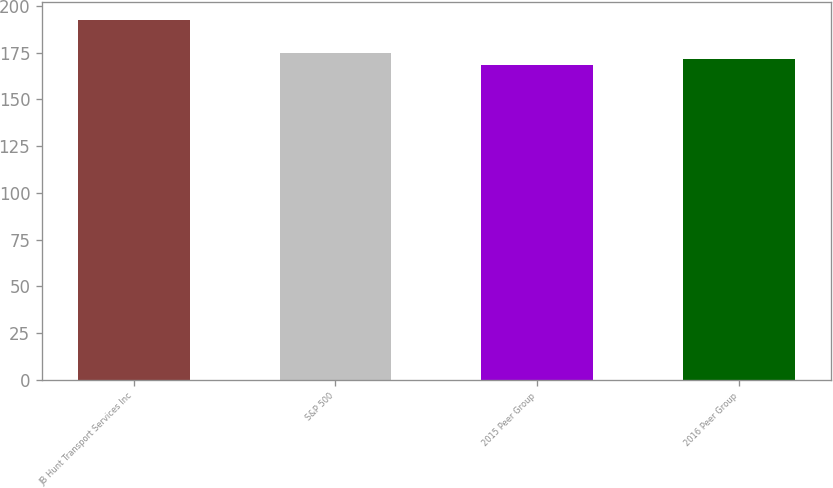Convert chart to OTSL. <chart><loc_0><loc_0><loc_500><loc_500><bar_chart><fcel>JB Hunt Transport Services Inc<fcel>S&P 500<fcel>2015 Peer Group<fcel>2016 Peer Group<nl><fcel>192.48<fcel>174.6<fcel>168.32<fcel>171.54<nl></chart> 